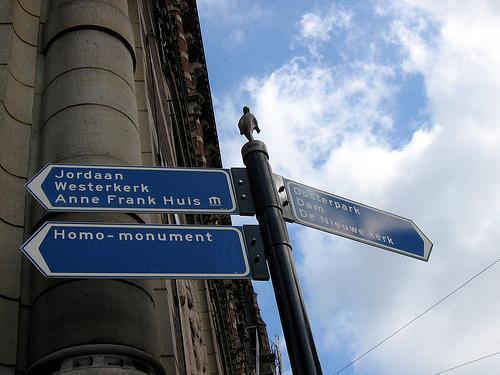How many signs are pointing left?
Give a very brief answer. 2. 